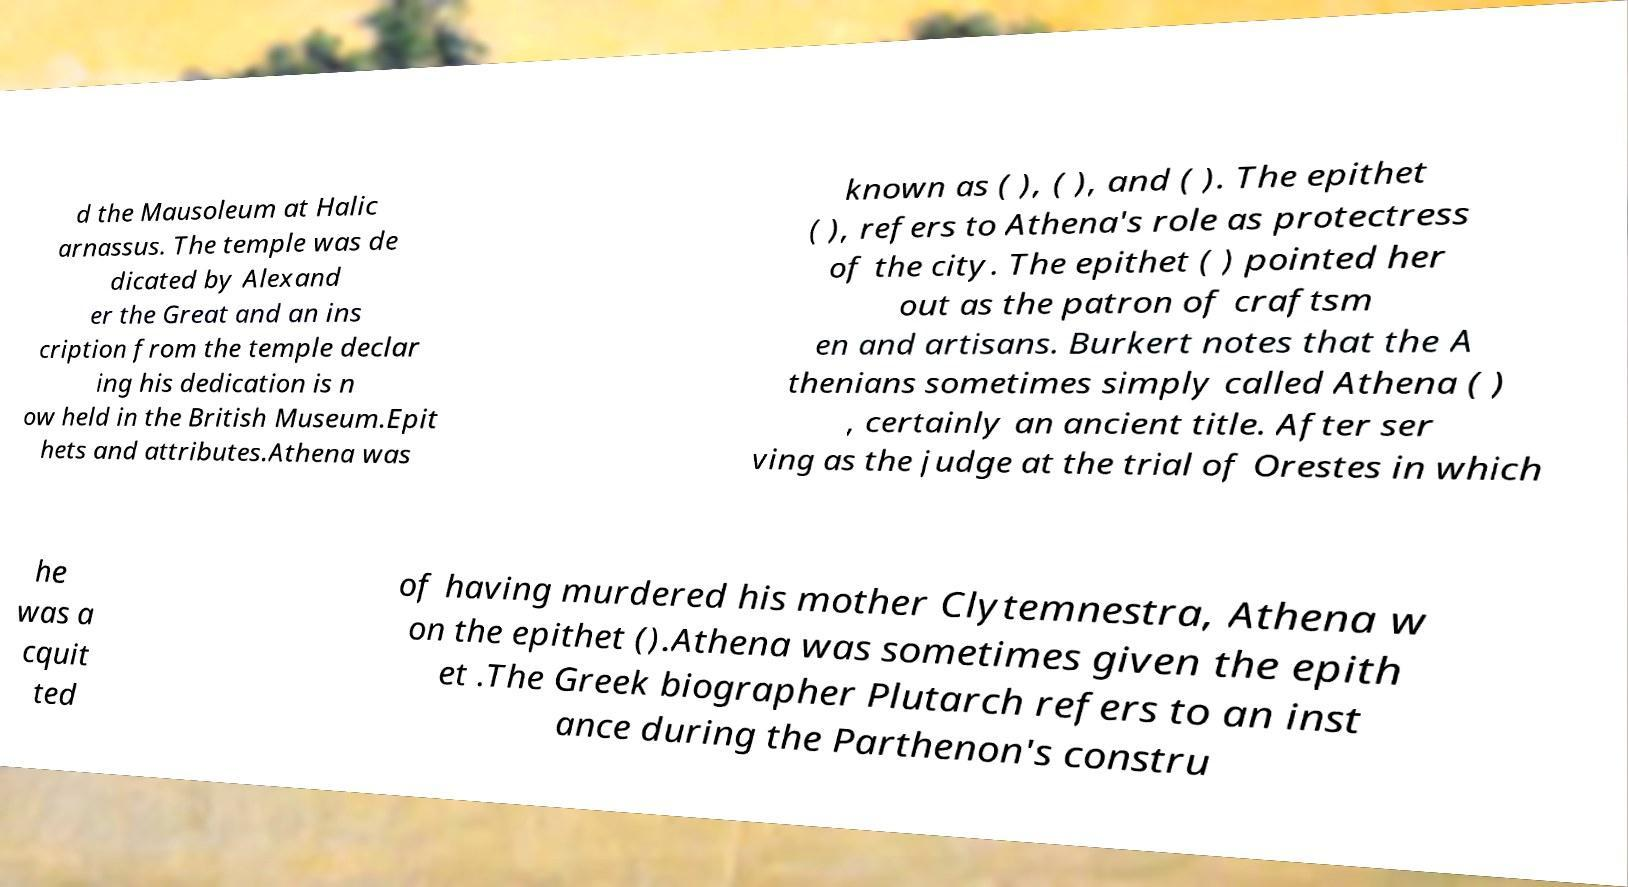Please identify and transcribe the text found in this image. d the Mausoleum at Halic arnassus. The temple was de dicated by Alexand er the Great and an ins cription from the temple declar ing his dedication is n ow held in the British Museum.Epit hets and attributes.Athena was known as ( ), ( ), and ( ). The epithet ( ), refers to Athena's role as protectress of the city. The epithet ( ) pointed her out as the patron of craftsm en and artisans. Burkert notes that the A thenians sometimes simply called Athena ( ) , certainly an ancient title. After ser ving as the judge at the trial of Orestes in which he was a cquit ted of having murdered his mother Clytemnestra, Athena w on the epithet ().Athena was sometimes given the epith et .The Greek biographer Plutarch refers to an inst ance during the Parthenon's constru 